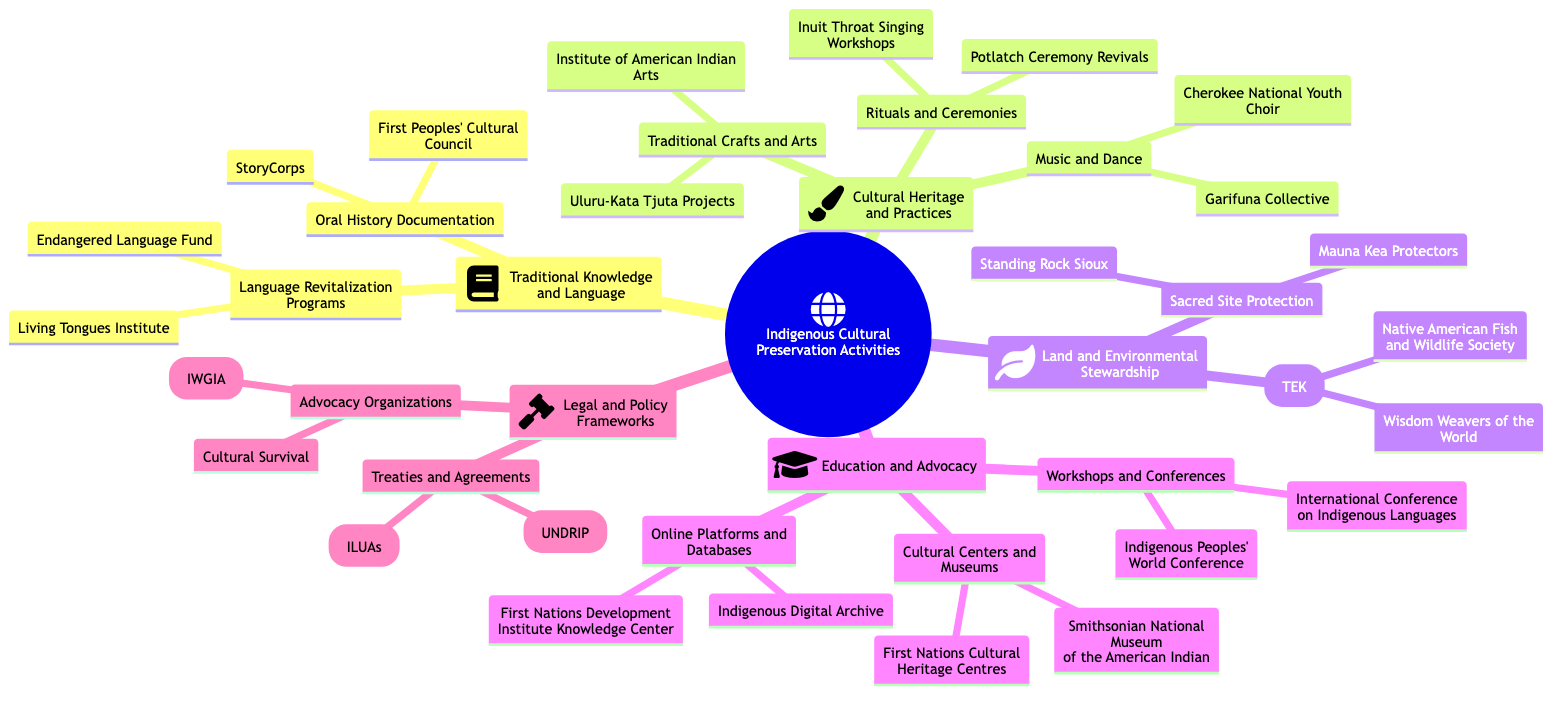What is the main category that encompasses "Language Revitalization Programs"? The diagram shows that "Language Revitalization Programs" is a subcategory under "Traditional Knowledge and Language," which is the main category.
Answer: Traditional Knowledge and Language How many examples are listed under "Traditional Crafts and Arts"? According to the diagram, there are two examples listed under "Traditional Crafts and Arts": "Institute of American Indian Arts" and "Uluru-Kata Tjuta Projects," which totals to two examples.
Answer: 2 What kind of knowledge is referenced under "Land and Environmental Stewardship"? The diagram indicates that "Traditional Ecological Knowledge (TEK" is a specific type of knowledge mentioned under "Land and Environmental Stewardship."
Answer: Traditional Ecological Knowledge (TEK) Which organization is associated with "Sacred Site Protection"? The diagram lists "Mauna Kea Protectors" and "Standing Rock Sioux" as examples associated with "Sacred Site Protection." Therefore, either organization can be a valid answer.
Answer: Mauna Kea Protectors How many main categories are identified in the diagram? Analyzing the diagram reveals there are five main categories: "Traditional Knowledge and Language," "Cultural Heritage and Practices," "Land and Environmental Stewardship," "Education and Advocacy," and "Legal and Policy Frameworks," totaling five main categories.
Answer: 5 What is one example given under "Online Platforms and Databases"? The diagram shows that "Indigenous Digital Archive" is one of the examples listed under "Online Platforms and Databases."
Answer: Indigenous Digital Archive Which conference is mentioned under "Workshops and Conferences"? The diagram points out "International Conference on Indigenous Languages" as one of the examples under "Workshops and Conferences."
Answer: International Conference on Indigenous Languages What is the function of "Education and Advocacy" in the diagram? "Education and Advocacy" serves as a main category that includes various subcategories and examples focused on education and support for indigenous rights and cultural preservation activities.
Answer: Education and Advocacy Which legal framework is highlighted in the section on treaties? In the diagram, "United Nations Declaration on the Rights of Indigenous Peoples (UNDRIP)" is one of the highlighted legal frameworks under the treaties section.
Answer: United Nations Declaration on the Rights of Indigenous Peoples (UNDRIP) 